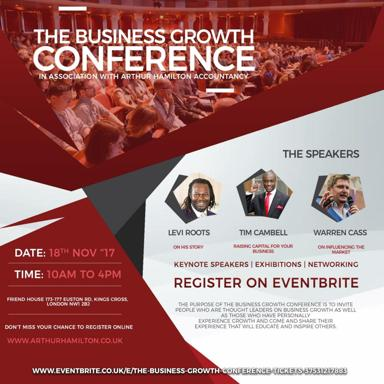How can attendees benefit from participating in this conference? Attendees can gain valuable insights from industry leaders, learn about new market trends, and connect with potential collaborators and investors. The knowledge and connections gained here are poised to significantly enhance their business strategies and growth potential. 